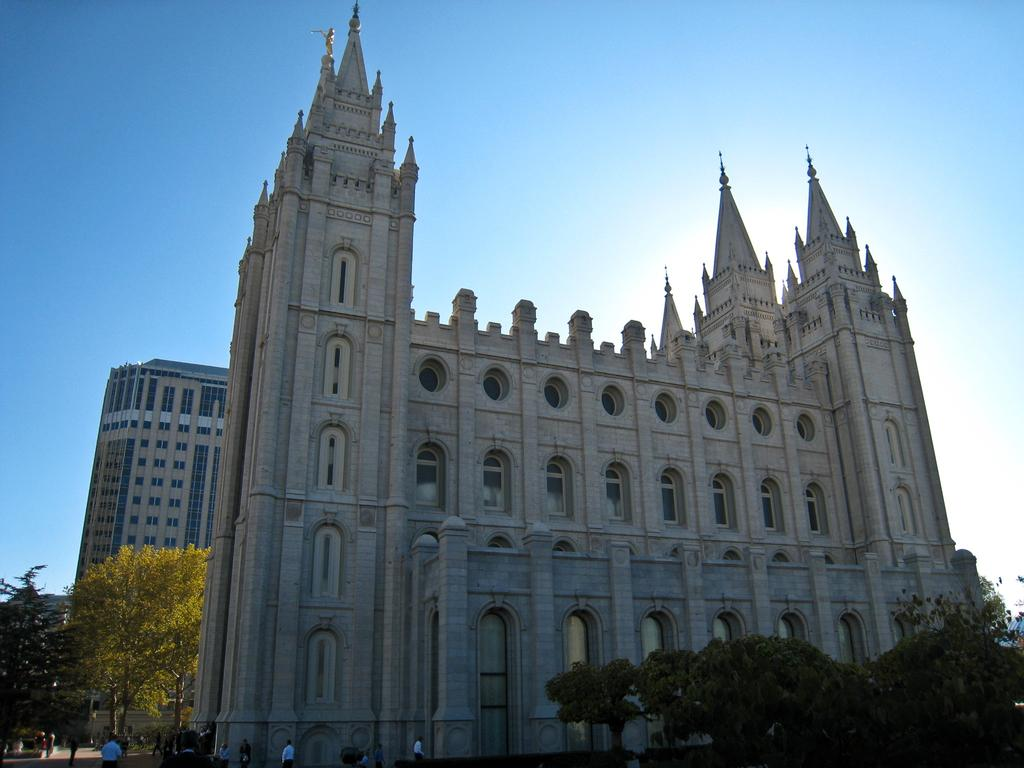What type of structures can be seen in the image? There are buildings in the image. What other natural elements are present in the image? There are trees in the image. What are the people in the image doing? There are people walking in the image. What is the condition of the sky in the image? The sky is clear in the image. What color is the shirt worn by the tree in the image? There is no shirt present on the tree in the image, as trees are not capable of wearing clothing. What type of work are the buildings in the image performing? The buildings in the image are not performing any work, as they are inanimate structures. 